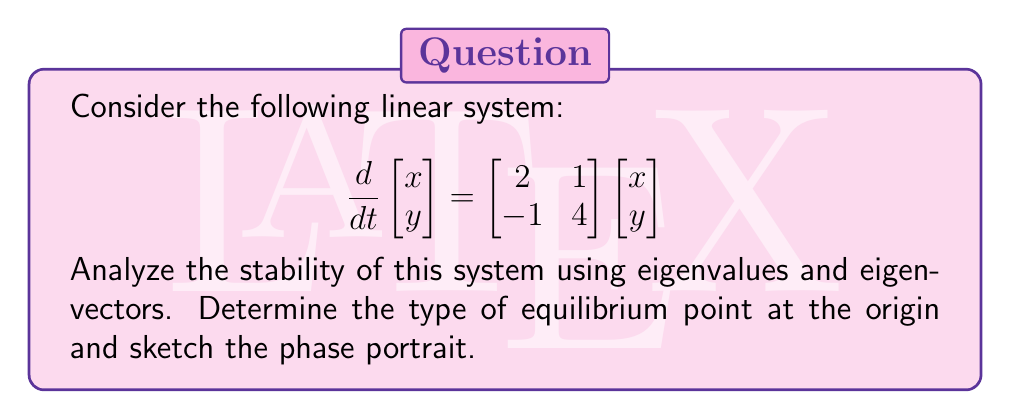Can you solve this math problem? Step 1: Find the eigenvalues of the coefficient matrix A.
$$A = \begin{bmatrix} 2 & 1 \\ -1 & 4 \end{bmatrix}$$
Characteristic equation: $det(A - \lambda I) = 0$
$$(2-\lambda)(4-\lambda) - (-1)(1) = 0$$
$$\lambda^2 - 6\lambda + 9 = 0$$
$$(λ-3)^2 = 0$$
Therefore, $\lambda_1 = \lambda_2 = 3$ (repeated eigenvalue)

Step 2: Find the eigenvectors.
For $\lambda = 3$:
$$(A - 3I)\vec{v} = \vec{0}$$
$$\begin{bmatrix} -1 & 1 \\ -1 & 1 \end{bmatrix}\begin{bmatrix} v_1 \\ v_2 \end{bmatrix} = \begin{bmatrix} 0 \\ 0 \end{bmatrix}$$
This gives us: $v_1 = v_2$
An eigenvector is: $\vec{v_1} = \begin{bmatrix} 1 \\ 1 \end{bmatrix}$

Step 3: Check for generalized eigenvector.
$(A - 3I)\vec{v_2} = \vec{v_1}$
$$\begin{bmatrix} -1 & 1 \\ -1 & 1 \end{bmatrix}\begin{bmatrix} v_{21} \\ v_{22} \end{bmatrix} = \begin{bmatrix} 1 \\ 1 \end{bmatrix}$$
This gives: $v_{22} - v_{21} = 1$
A generalized eigenvector is: $\vec{v_2} = \begin{bmatrix} 0 \\ 1 \end{bmatrix}$

Step 4: Analyze stability.
The repeated eigenvalue is positive (λ = 3 > 0), indicating an unstable system.

Step 5: Determine the type of equilibrium.
With a repeated positive eigenvalue and a generalized eigenvector, the origin is an unstable improper node.

Step 6: Sketch the phase portrait.
The general solution is:
$$\vec{x}(t) = c_1e^{3t}\vec{v_1} + c_2e^{3t}(t\vec{v_1} + \vec{v_2})$$
This shows exponential growth with a linear term, creating trajectories that move away from the origin in parabolic paths.

[asy]
import graph;
size(200);
xaxis("x", arrow=Arrow);
yaxis("y", arrow=Arrow);
for (real t = -2; t <= 2; t += 0.5) {
  draw((t,-2)--(t,2), gray+dashed);
  draw((-2,t)--(2,t), gray+dashed);
}
for (real t = -1; t <= 1; t += 0.25) {
  path p = (t,-2){dir(70)}..{dir(20)}(2,2*t);
  draw(p, blue, arrow=Arrow);
  draw(reflect((0,0),(1,1))*p, blue, arrow=Arrow);
}
dot((0,0));
label("Unstable Improper Node", (1.5,-1.5), fontsize(8));
[/asy]
Answer: Unstable improper node at origin; λ₁ = λ₂ = 3 > 0 